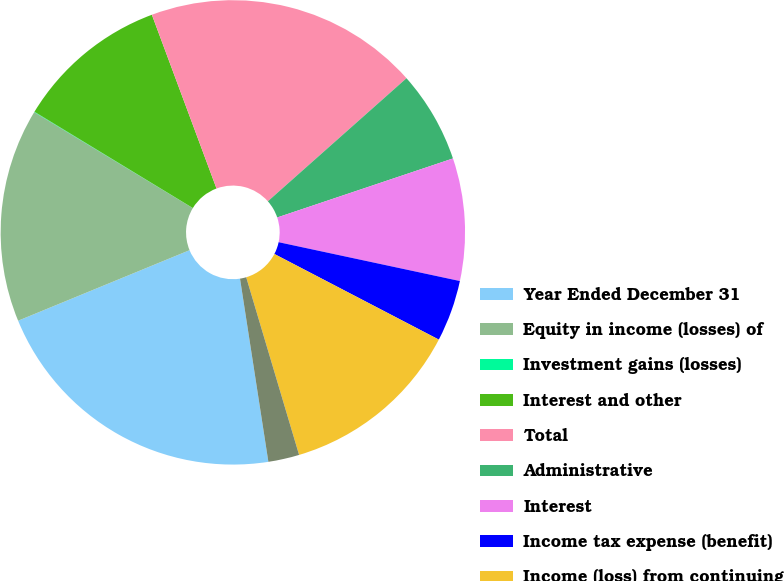Convert chart. <chart><loc_0><loc_0><loc_500><loc_500><pie_chart><fcel>Year Ended December 31<fcel>Equity in income (losses) of<fcel>Investment gains (losses)<fcel>Interest and other<fcel>Total<fcel>Administrative<fcel>Interest<fcel>Income tax expense (benefit)<fcel>Income (loss) from continuing<fcel>Discontinued operations net<nl><fcel>21.24%<fcel>14.88%<fcel>0.03%<fcel>10.64%<fcel>19.12%<fcel>6.4%<fcel>8.52%<fcel>4.28%<fcel>12.76%<fcel>2.16%<nl></chart> 